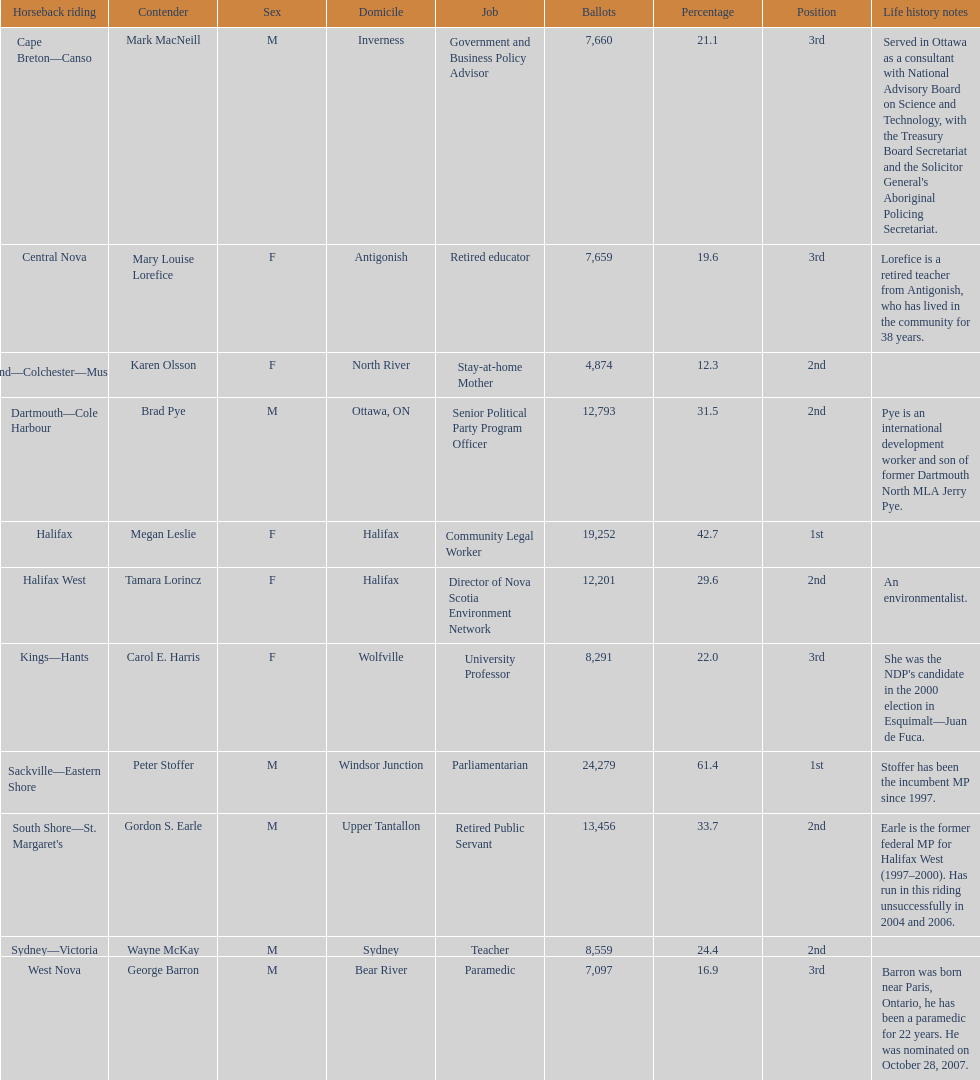What's the sum of all the candidates? 11. 